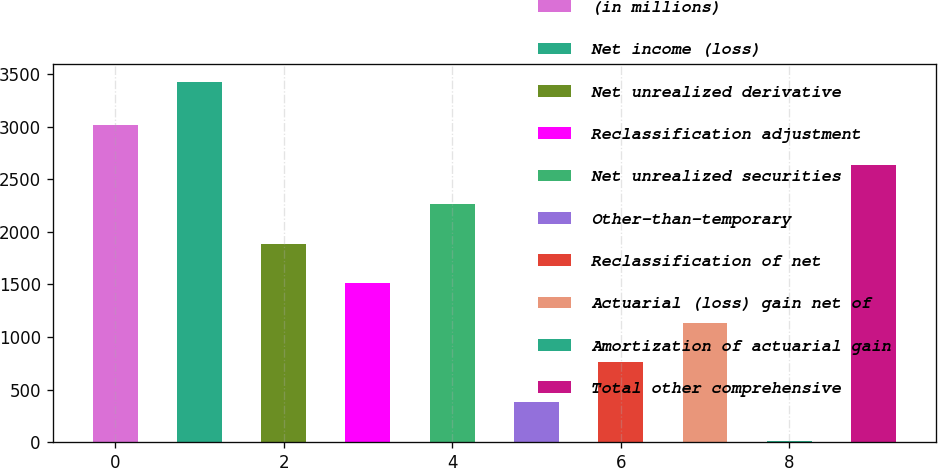Convert chart to OTSL. <chart><loc_0><loc_0><loc_500><loc_500><bar_chart><fcel>(in millions)<fcel>Net income (loss)<fcel>Net unrealized derivative<fcel>Reclassification adjustment<fcel>Net unrealized securities<fcel>Other-than-temporary<fcel>Reclassification of net<fcel>Actuarial (loss) gain net of<fcel>Amortization of actuarial gain<fcel>Total other comprehensive<nl><fcel>3011.4<fcel>3426<fcel>1885.5<fcel>1510.2<fcel>2260.8<fcel>384.3<fcel>759.6<fcel>1134.9<fcel>9<fcel>2636.1<nl></chart> 